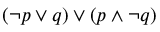<formula> <loc_0><loc_0><loc_500><loc_500>( \neg p \lor q ) \lor ( p \land \neg q )</formula> 